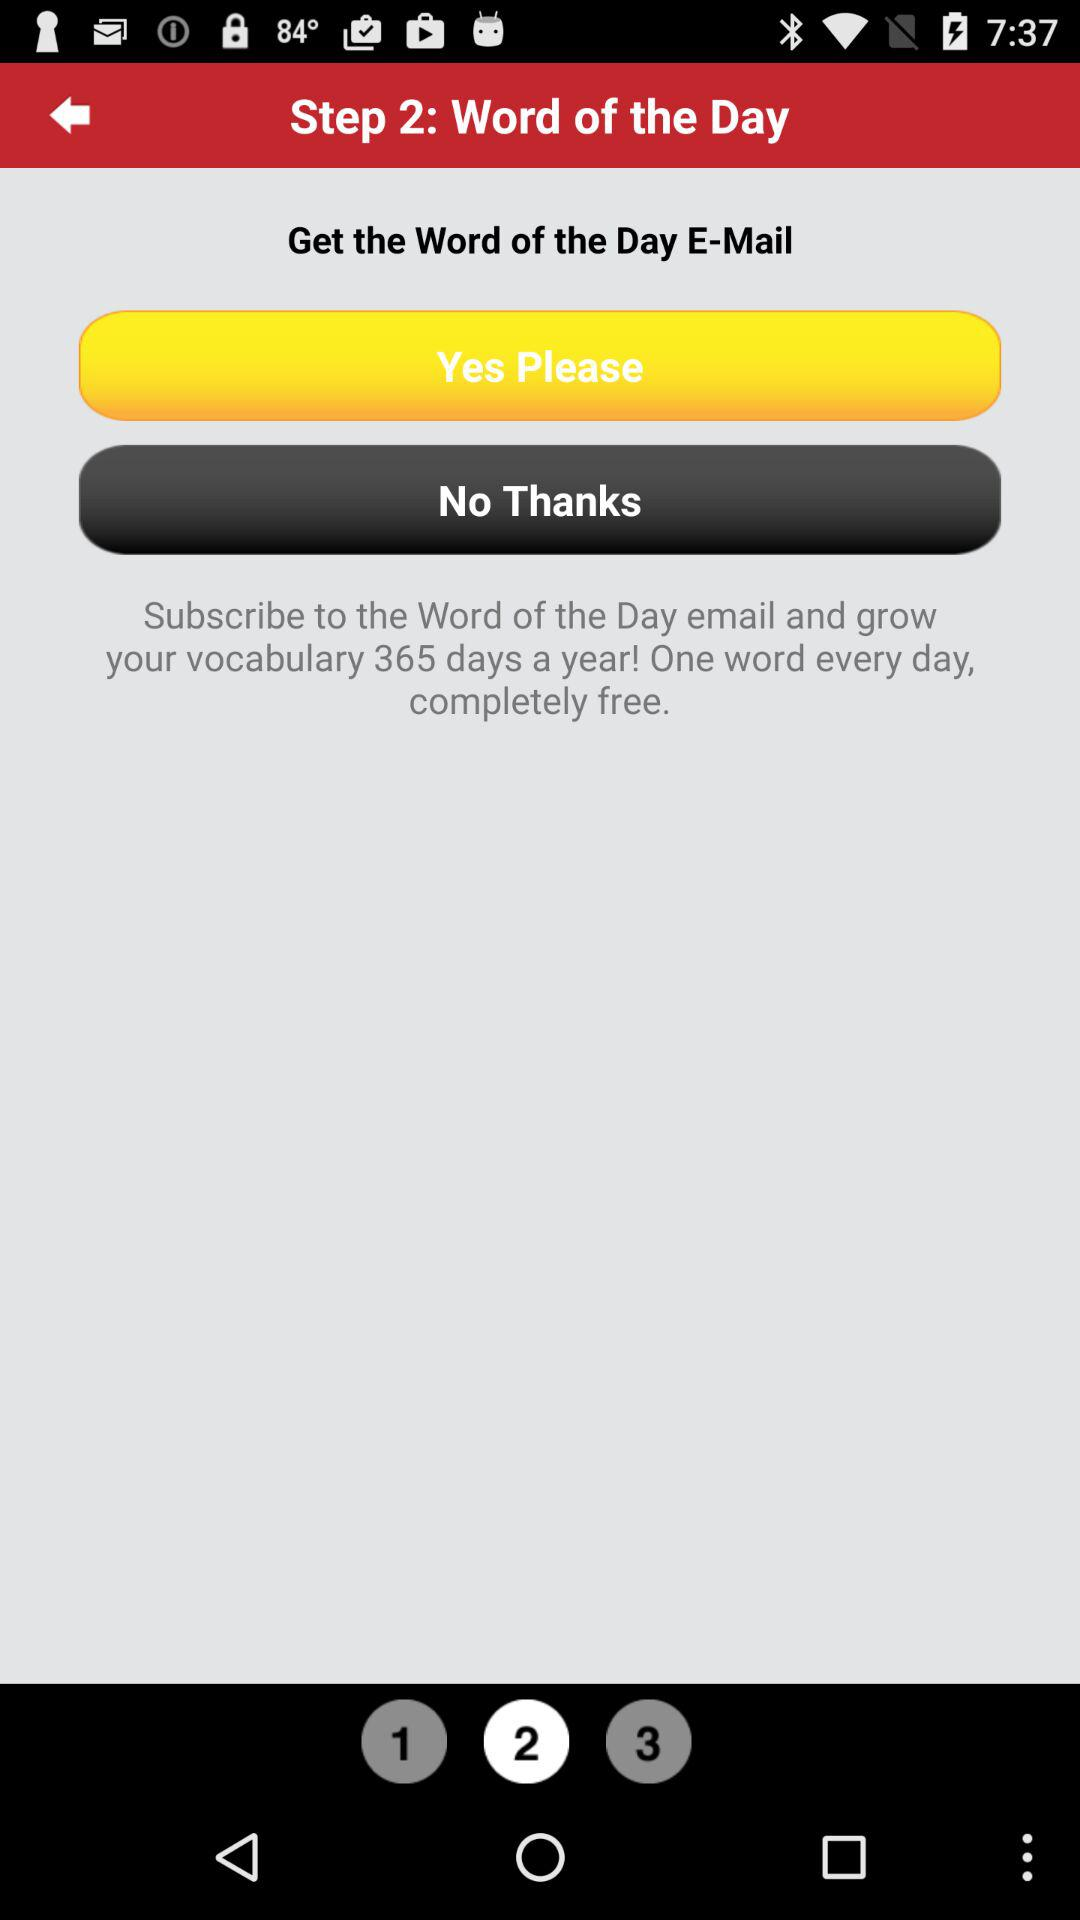Which step are we currently on? You are currently on step 2. 